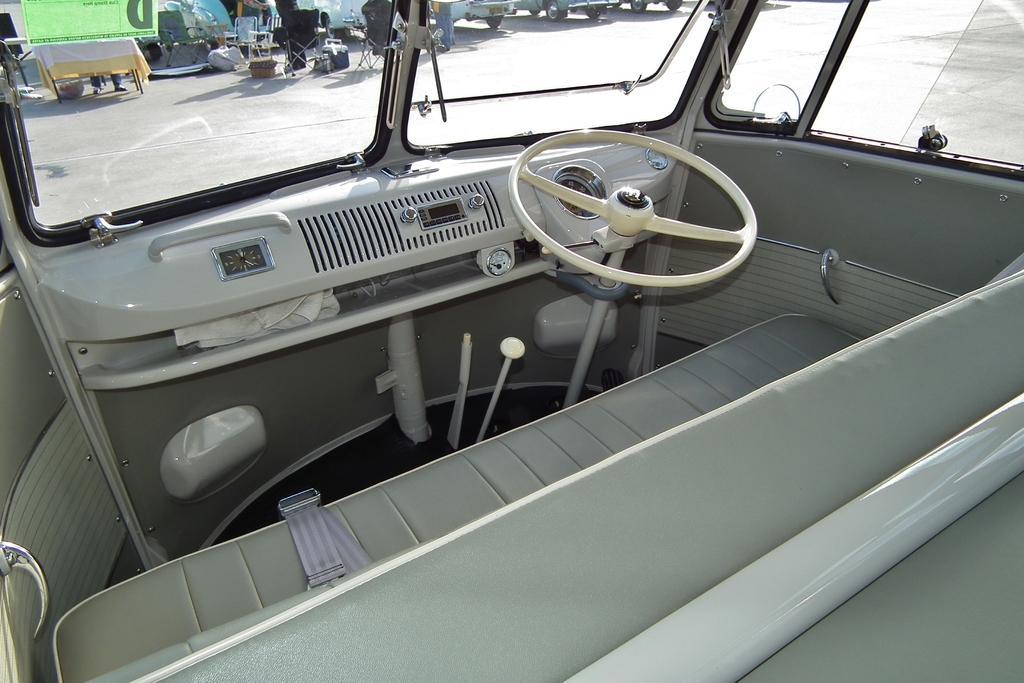Can you describe this image briefly? In this image we can see the inside view of the vehicle that includes the steering wheel, seats and windows. 